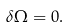<formula> <loc_0><loc_0><loc_500><loc_500>\delta \Omega = 0 .</formula> 